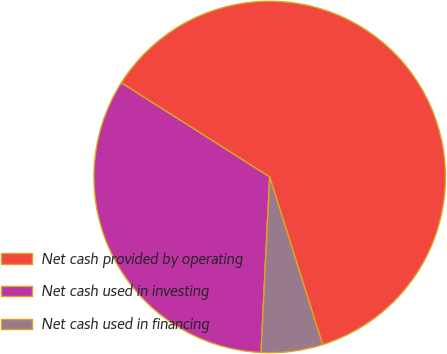Convert chart. <chart><loc_0><loc_0><loc_500><loc_500><pie_chart><fcel>Net cash provided by operating<fcel>Net cash used in investing<fcel>Net cash used in financing<nl><fcel>61.13%<fcel>33.21%<fcel>5.66%<nl></chart> 